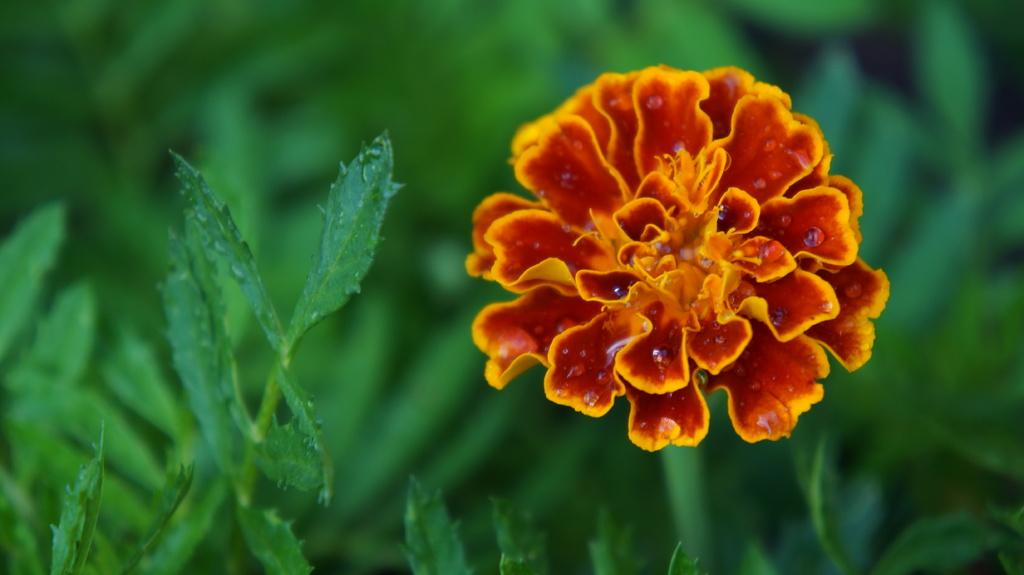What type of living organisms can be seen in the image? Plants and a flower are visible in the image. Can you describe the flower in the image? The flower is a prominent feature in the image. What is the appearance of the background in the image? The background of the image is blurred. What type of clam is visible in the image? There is no clam present in the image; it features plants and a flower. Are there any shoes or skirts visible in the image? No, there are no shoes or skirts present in the image. 